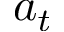<formula> <loc_0><loc_0><loc_500><loc_500>a _ { t }</formula> 